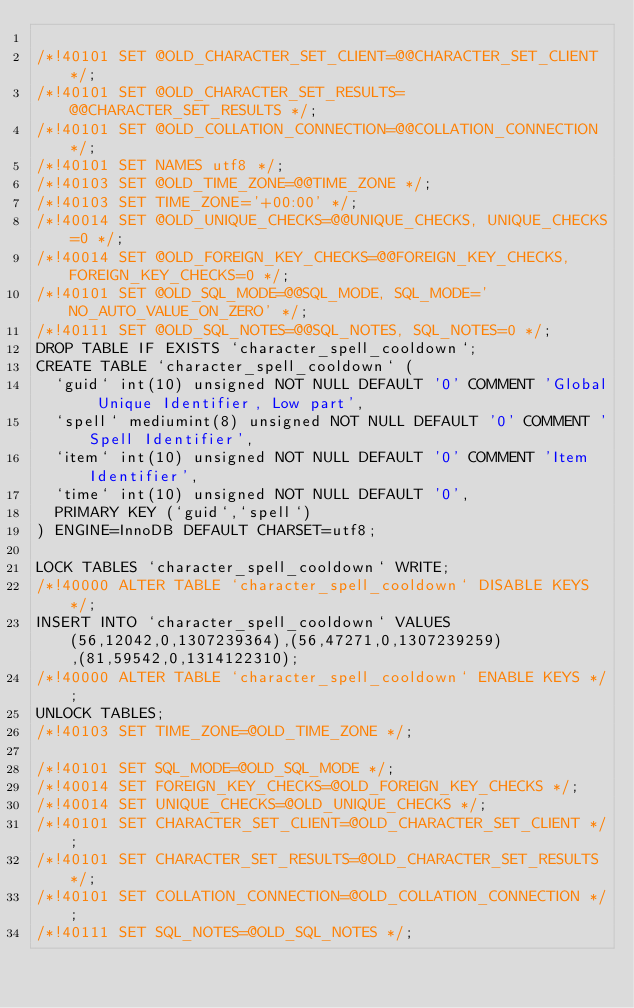<code> <loc_0><loc_0><loc_500><loc_500><_SQL_>
/*!40101 SET @OLD_CHARACTER_SET_CLIENT=@@CHARACTER_SET_CLIENT */;
/*!40101 SET @OLD_CHARACTER_SET_RESULTS=@@CHARACTER_SET_RESULTS */;
/*!40101 SET @OLD_COLLATION_CONNECTION=@@COLLATION_CONNECTION */;
/*!40101 SET NAMES utf8 */;
/*!40103 SET @OLD_TIME_ZONE=@@TIME_ZONE */;
/*!40103 SET TIME_ZONE='+00:00' */;
/*!40014 SET @OLD_UNIQUE_CHECKS=@@UNIQUE_CHECKS, UNIQUE_CHECKS=0 */;
/*!40014 SET @OLD_FOREIGN_KEY_CHECKS=@@FOREIGN_KEY_CHECKS, FOREIGN_KEY_CHECKS=0 */;
/*!40101 SET @OLD_SQL_MODE=@@SQL_MODE, SQL_MODE='NO_AUTO_VALUE_ON_ZERO' */;
/*!40111 SET @OLD_SQL_NOTES=@@SQL_NOTES, SQL_NOTES=0 */;
DROP TABLE IF EXISTS `character_spell_cooldown`;
CREATE TABLE `character_spell_cooldown` (
  `guid` int(10) unsigned NOT NULL DEFAULT '0' COMMENT 'Global Unique Identifier, Low part',
  `spell` mediumint(8) unsigned NOT NULL DEFAULT '0' COMMENT 'Spell Identifier',
  `item` int(10) unsigned NOT NULL DEFAULT '0' COMMENT 'Item Identifier',
  `time` int(10) unsigned NOT NULL DEFAULT '0',
  PRIMARY KEY (`guid`,`spell`)
) ENGINE=InnoDB DEFAULT CHARSET=utf8;

LOCK TABLES `character_spell_cooldown` WRITE;
/*!40000 ALTER TABLE `character_spell_cooldown` DISABLE KEYS */;
INSERT INTO `character_spell_cooldown` VALUES (56,12042,0,1307239364),(56,47271,0,1307239259),(81,59542,0,1314122310);
/*!40000 ALTER TABLE `character_spell_cooldown` ENABLE KEYS */;
UNLOCK TABLES;
/*!40103 SET TIME_ZONE=@OLD_TIME_ZONE */;

/*!40101 SET SQL_MODE=@OLD_SQL_MODE */;
/*!40014 SET FOREIGN_KEY_CHECKS=@OLD_FOREIGN_KEY_CHECKS */;
/*!40014 SET UNIQUE_CHECKS=@OLD_UNIQUE_CHECKS */;
/*!40101 SET CHARACTER_SET_CLIENT=@OLD_CHARACTER_SET_CLIENT */;
/*!40101 SET CHARACTER_SET_RESULTS=@OLD_CHARACTER_SET_RESULTS */;
/*!40101 SET COLLATION_CONNECTION=@OLD_COLLATION_CONNECTION */;
/*!40111 SET SQL_NOTES=@OLD_SQL_NOTES */;

</code> 